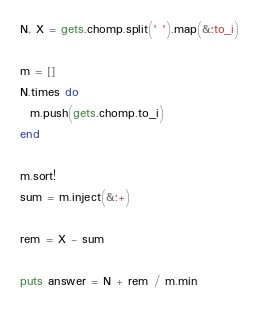Convert code to text. <code><loc_0><loc_0><loc_500><loc_500><_Ruby_>N, X = gets.chomp.split(' ').map(&:to_i)
 
m = []
N.times do
  m.push(gets.chomp.to_i)
end
 
m.sort!
sum = m.inject(&:+)
 
rem = X - sum
 
puts answer = N + rem / m.min</code> 